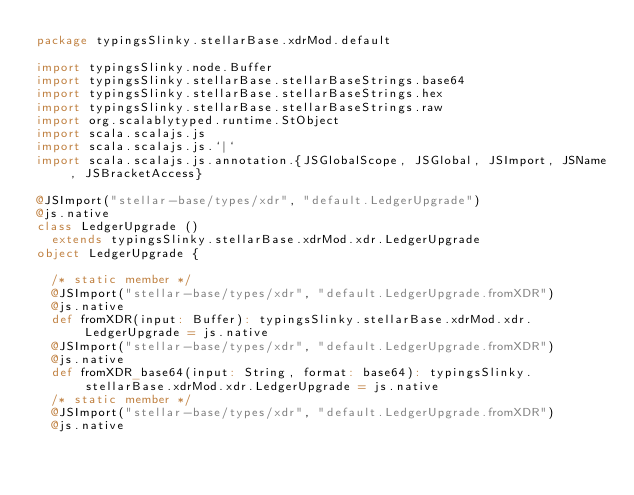<code> <loc_0><loc_0><loc_500><loc_500><_Scala_>package typingsSlinky.stellarBase.xdrMod.default

import typingsSlinky.node.Buffer
import typingsSlinky.stellarBase.stellarBaseStrings.base64
import typingsSlinky.stellarBase.stellarBaseStrings.hex
import typingsSlinky.stellarBase.stellarBaseStrings.raw
import org.scalablytyped.runtime.StObject
import scala.scalajs.js
import scala.scalajs.js.`|`
import scala.scalajs.js.annotation.{JSGlobalScope, JSGlobal, JSImport, JSName, JSBracketAccess}

@JSImport("stellar-base/types/xdr", "default.LedgerUpgrade")
@js.native
class LedgerUpgrade ()
  extends typingsSlinky.stellarBase.xdrMod.xdr.LedgerUpgrade
object LedgerUpgrade {
  
  /* static member */
  @JSImport("stellar-base/types/xdr", "default.LedgerUpgrade.fromXDR")
  @js.native
  def fromXDR(input: Buffer): typingsSlinky.stellarBase.xdrMod.xdr.LedgerUpgrade = js.native
  @JSImport("stellar-base/types/xdr", "default.LedgerUpgrade.fromXDR")
  @js.native
  def fromXDR_base64(input: String, format: base64): typingsSlinky.stellarBase.xdrMod.xdr.LedgerUpgrade = js.native
  /* static member */
  @JSImport("stellar-base/types/xdr", "default.LedgerUpgrade.fromXDR")
  @js.native</code> 